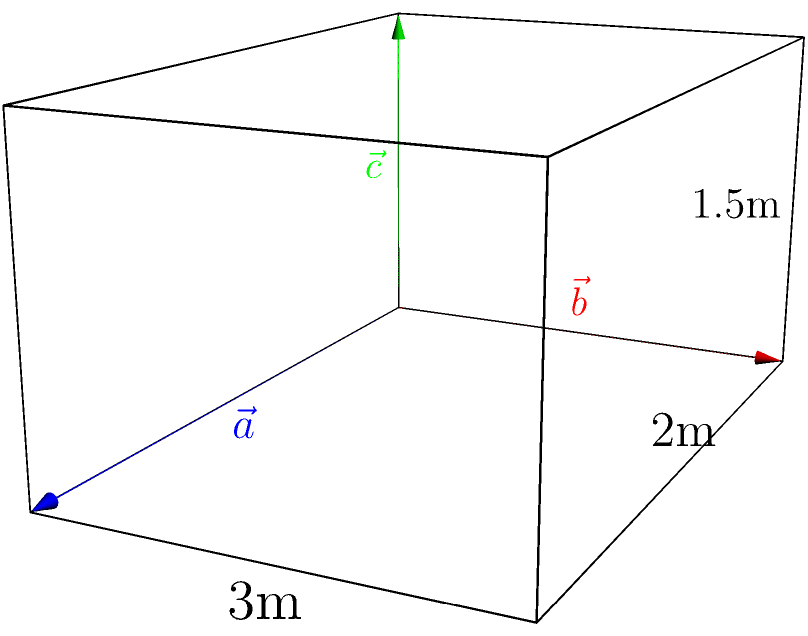A mikveh (ritual bath) is represented by three vectors: $\vec{a} = 3\hat{i}$, $\vec{b} = 2\hat{j}$, and $\vec{c} = 1.5\hat{k}$ (all measurements in meters). Calculate the volume of the mikveh using vector operations, and determine if it meets the minimum requirement of 40 se'ah (approximately 500 liters) according to Halacha. To solve this problem, we'll follow these steps:

1) The volume of the mikveh can be calculated using the scalar triple product of the three vectors:
   $V = |\vec{a} \cdot (\vec{b} \times \vec{c})|$

2) First, let's calculate $\vec{b} \times \vec{c}$:
   $\vec{b} \times \vec{c} = (2\hat{j}) \times (1.5\hat{k}) = 3\hat{i}$

3) Now, we can calculate the scalar triple product:
   $V = |\vec{a} \cdot (\vec{b} \times \vec{c})| = |(3\hat{i}) \cdot (3\hat{i})| = |9| = 9$ cubic meters

4) To convert cubic meters to liters:
   $9 \text{ m}^3 = 9000 \text{ liters}$

5) Compare with the minimum requirement:
   $9000 \text{ liters} > 500 \text{ liters}$

Therefore, the mikveh's volume is 9000 liters, which significantly exceeds the minimum requirement of approximately 500 liters (40 se'ah) according to Halacha.
Answer: 9000 liters; meets requirement 